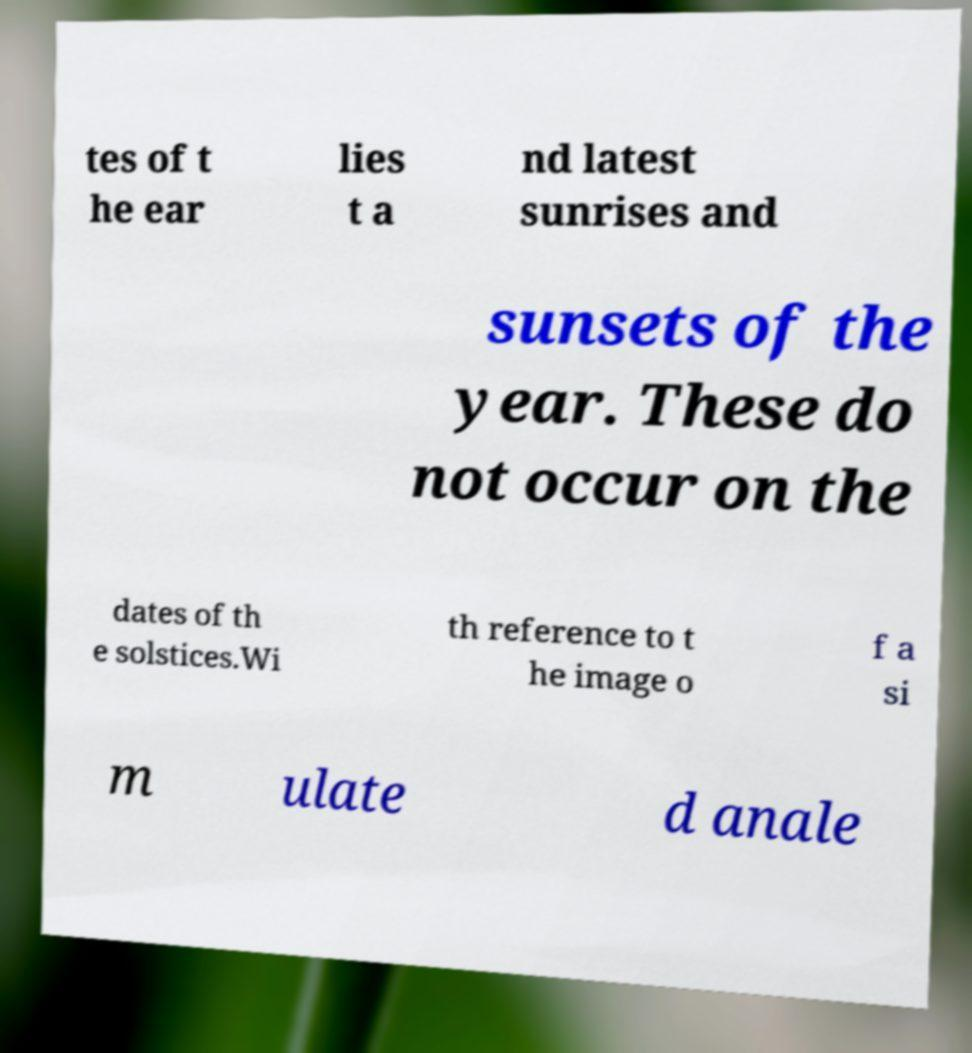Could you extract and type out the text from this image? tes of t he ear lies t a nd latest sunrises and sunsets of the year. These do not occur on the dates of th e solstices.Wi th reference to t he image o f a si m ulate d anale 